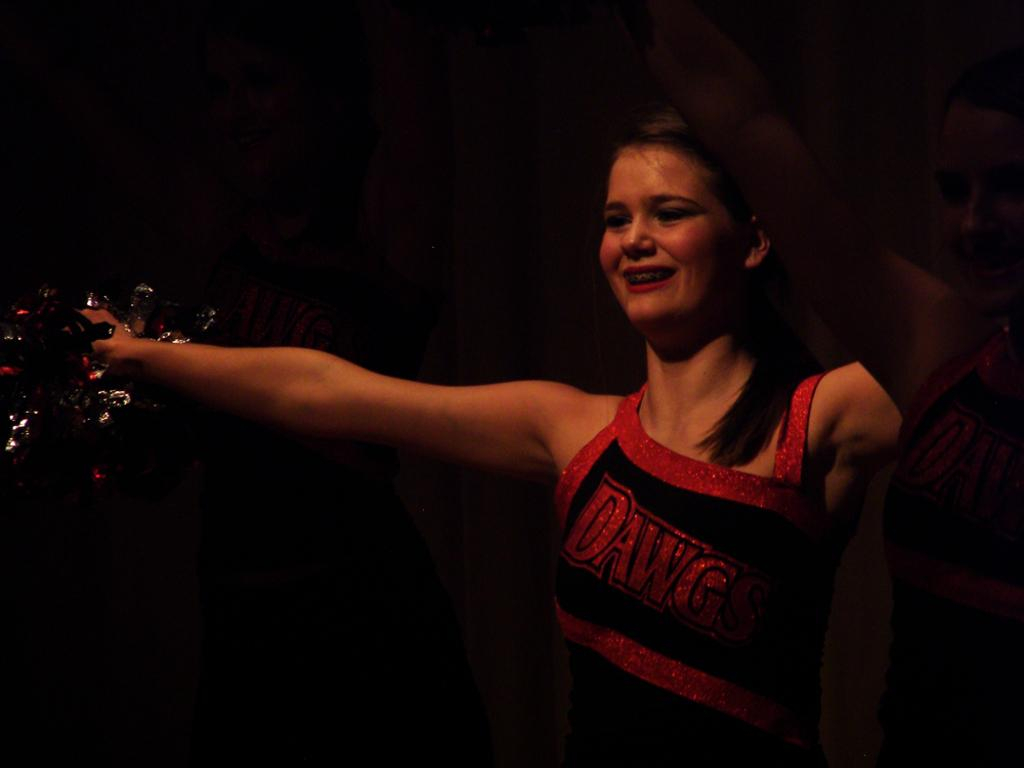What is the woman in the image doing? The woman is smiling in the image. What is the woman holding in her hand? The woman is holding a color paper in her hand. How many women are present in the image? There are two women present in the image. What is the woman's stomach doing in the image? There is no specific information about the woman's stomach in the image, so it cannot be described. 